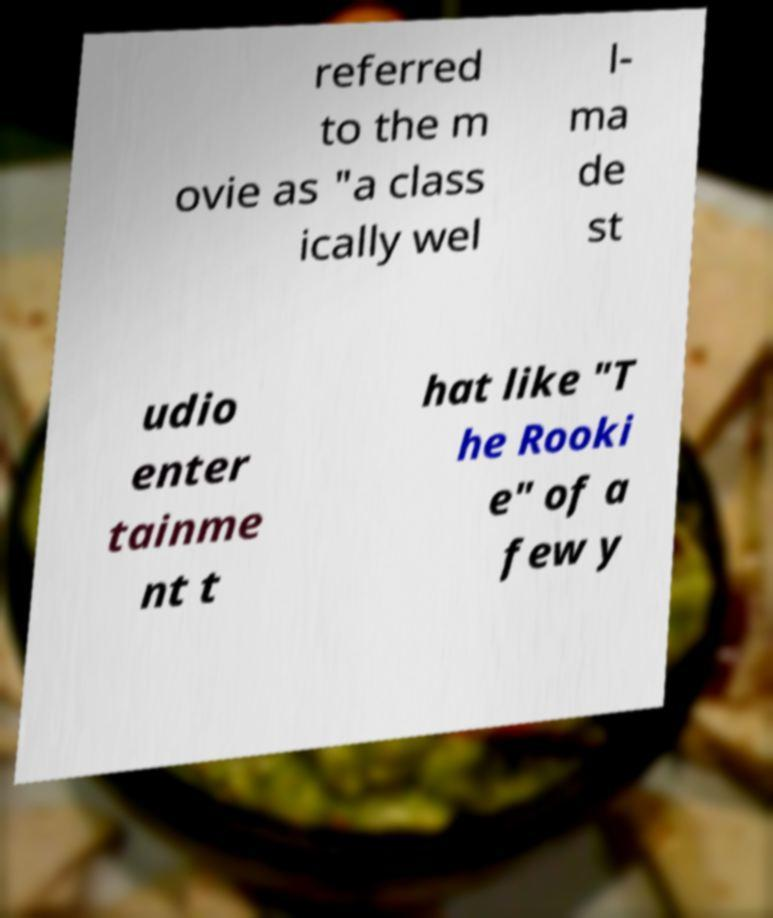Could you assist in decoding the text presented in this image and type it out clearly? referred to the m ovie as "a class ically wel l- ma de st udio enter tainme nt t hat like "T he Rooki e" of a few y 